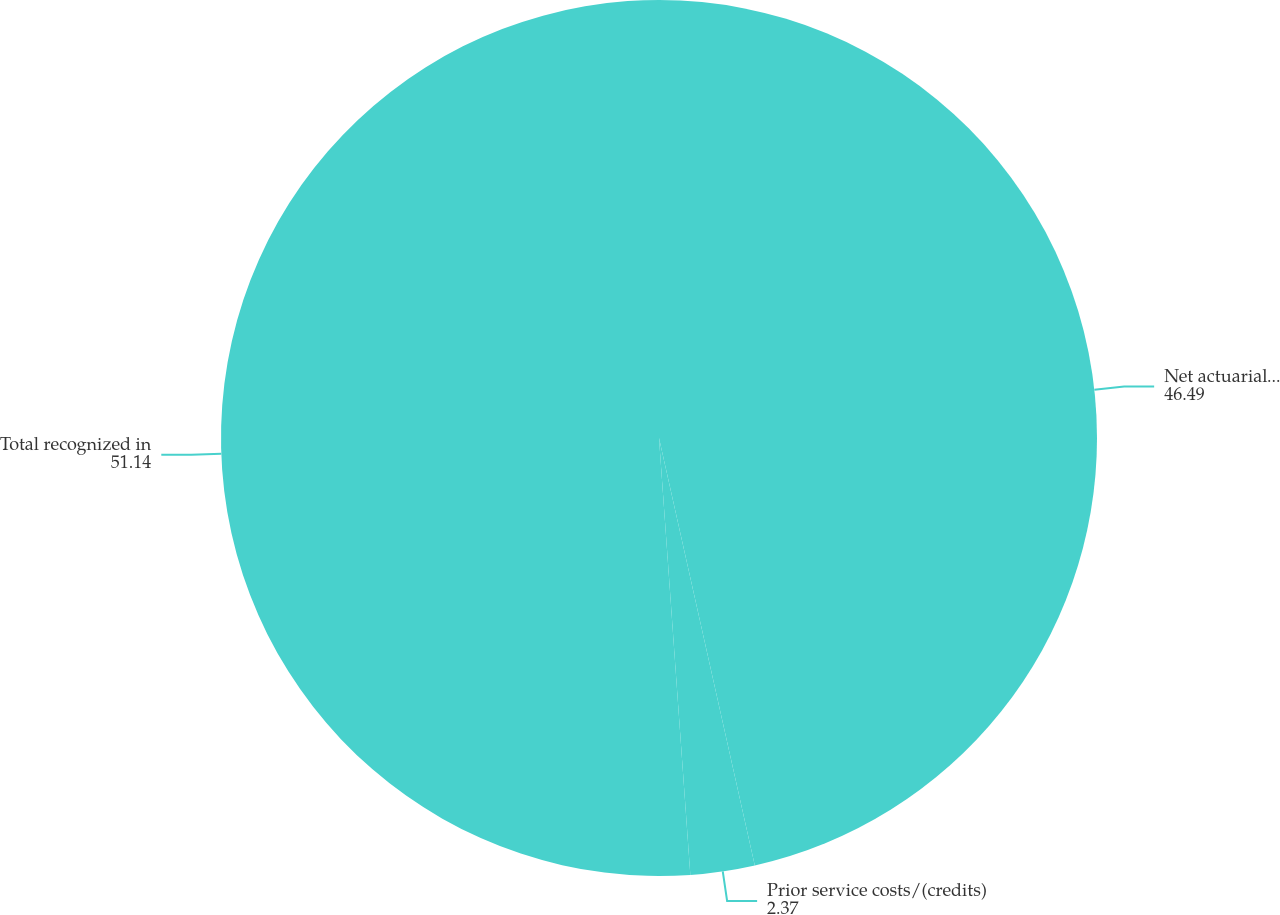Convert chart to OTSL. <chart><loc_0><loc_0><loc_500><loc_500><pie_chart><fcel>Net actuarial loss<fcel>Prior service costs/(credits)<fcel>Total recognized in<nl><fcel>46.49%<fcel>2.37%<fcel>51.14%<nl></chart> 